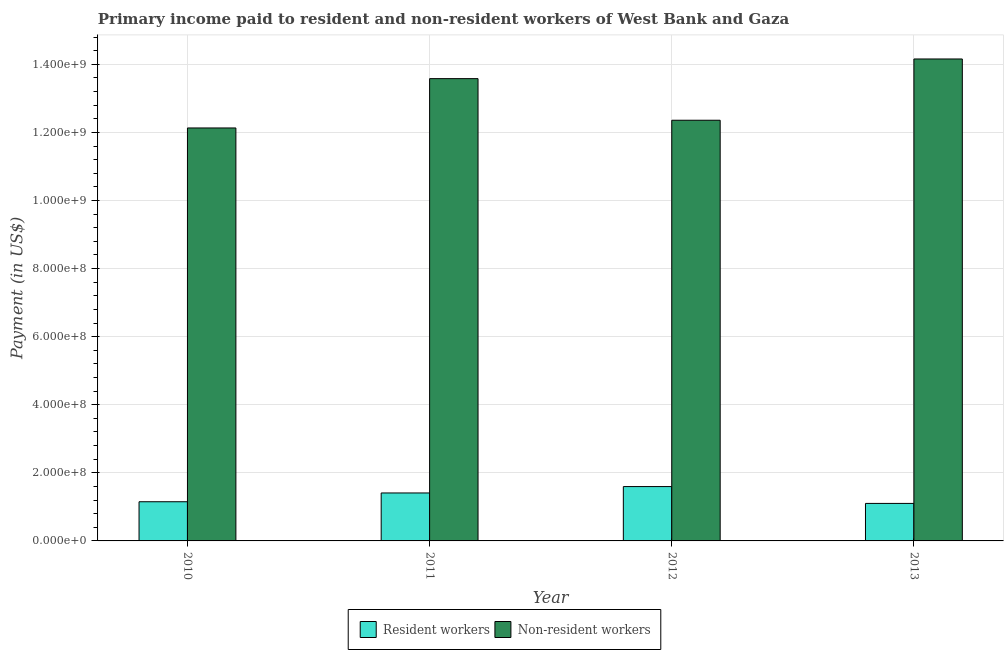How many different coloured bars are there?
Ensure brevity in your answer.  2. Are the number of bars per tick equal to the number of legend labels?
Your answer should be compact. Yes. Are the number of bars on each tick of the X-axis equal?
Your answer should be very brief. Yes. How many bars are there on the 4th tick from the right?
Your response must be concise. 2. What is the label of the 1st group of bars from the left?
Keep it short and to the point. 2010. What is the payment made to resident workers in 2013?
Your response must be concise. 1.10e+08. Across all years, what is the maximum payment made to resident workers?
Your answer should be compact. 1.60e+08. Across all years, what is the minimum payment made to non-resident workers?
Your answer should be very brief. 1.21e+09. In which year was the payment made to resident workers maximum?
Your response must be concise. 2012. In which year was the payment made to resident workers minimum?
Make the answer very short. 2013. What is the total payment made to resident workers in the graph?
Your answer should be very brief. 5.26e+08. What is the difference between the payment made to resident workers in 2010 and that in 2011?
Provide a succinct answer. -2.58e+07. What is the difference between the payment made to resident workers in 2011 and the payment made to non-resident workers in 2010?
Make the answer very short. 2.58e+07. What is the average payment made to resident workers per year?
Keep it short and to the point. 1.31e+08. In the year 2010, what is the difference between the payment made to resident workers and payment made to non-resident workers?
Provide a short and direct response. 0. What is the ratio of the payment made to non-resident workers in 2010 to that in 2013?
Provide a succinct answer. 0.86. Is the payment made to resident workers in 2011 less than that in 2012?
Your response must be concise. Yes. Is the difference between the payment made to resident workers in 2010 and 2011 greater than the difference between the payment made to non-resident workers in 2010 and 2011?
Offer a very short reply. No. What is the difference between the highest and the second highest payment made to non-resident workers?
Provide a succinct answer. 5.78e+07. What is the difference between the highest and the lowest payment made to resident workers?
Ensure brevity in your answer.  4.95e+07. Is the sum of the payment made to non-resident workers in 2011 and 2012 greater than the maximum payment made to resident workers across all years?
Offer a terse response. Yes. What does the 1st bar from the left in 2012 represents?
Keep it short and to the point. Resident workers. What does the 1st bar from the right in 2012 represents?
Provide a succinct answer. Non-resident workers. How many bars are there?
Give a very brief answer. 8. Are all the bars in the graph horizontal?
Provide a short and direct response. No. Are the values on the major ticks of Y-axis written in scientific E-notation?
Offer a very short reply. Yes. Does the graph contain any zero values?
Give a very brief answer. No. What is the title of the graph?
Provide a succinct answer. Primary income paid to resident and non-resident workers of West Bank and Gaza. Does "Nitrous oxide emissions" appear as one of the legend labels in the graph?
Ensure brevity in your answer.  No. What is the label or title of the Y-axis?
Give a very brief answer. Payment (in US$). What is the Payment (in US$) in Resident workers in 2010?
Ensure brevity in your answer.  1.15e+08. What is the Payment (in US$) in Non-resident workers in 2010?
Make the answer very short. 1.21e+09. What is the Payment (in US$) in Resident workers in 2011?
Provide a short and direct response. 1.41e+08. What is the Payment (in US$) of Non-resident workers in 2011?
Your response must be concise. 1.36e+09. What is the Payment (in US$) in Resident workers in 2012?
Give a very brief answer. 1.60e+08. What is the Payment (in US$) in Non-resident workers in 2012?
Provide a short and direct response. 1.24e+09. What is the Payment (in US$) in Resident workers in 2013?
Your answer should be compact. 1.10e+08. What is the Payment (in US$) in Non-resident workers in 2013?
Offer a very short reply. 1.42e+09. Across all years, what is the maximum Payment (in US$) of Resident workers?
Offer a very short reply. 1.60e+08. Across all years, what is the maximum Payment (in US$) in Non-resident workers?
Your answer should be very brief. 1.42e+09. Across all years, what is the minimum Payment (in US$) of Resident workers?
Offer a very short reply. 1.10e+08. Across all years, what is the minimum Payment (in US$) in Non-resident workers?
Your response must be concise. 1.21e+09. What is the total Payment (in US$) in Resident workers in the graph?
Give a very brief answer. 5.26e+08. What is the total Payment (in US$) of Non-resident workers in the graph?
Provide a succinct answer. 5.22e+09. What is the difference between the Payment (in US$) in Resident workers in 2010 and that in 2011?
Your response must be concise. -2.58e+07. What is the difference between the Payment (in US$) in Non-resident workers in 2010 and that in 2011?
Keep it short and to the point. -1.45e+08. What is the difference between the Payment (in US$) of Resident workers in 2010 and that in 2012?
Make the answer very short. -4.46e+07. What is the difference between the Payment (in US$) in Non-resident workers in 2010 and that in 2012?
Provide a short and direct response. -2.27e+07. What is the difference between the Payment (in US$) of Resident workers in 2010 and that in 2013?
Your response must be concise. 4.90e+06. What is the difference between the Payment (in US$) of Non-resident workers in 2010 and that in 2013?
Offer a terse response. -2.03e+08. What is the difference between the Payment (in US$) of Resident workers in 2011 and that in 2012?
Your response must be concise. -1.88e+07. What is the difference between the Payment (in US$) in Non-resident workers in 2011 and that in 2012?
Provide a short and direct response. 1.22e+08. What is the difference between the Payment (in US$) in Resident workers in 2011 and that in 2013?
Offer a very short reply. 3.07e+07. What is the difference between the Payment (in US$) in Non-resident workers in 2011 and that in 2013?
Offer a terse response. -5.78e+07. What is the difference between the Payment (in US$) of Resident workers in 2012 and that in 2013?
Ensure brevity in your answer.  4.95e+07. What is the difference between the Payment (in US$) of Non-resident workers in 2012 and that in 2013?
Your answer should be very brief. -1.80e+08. What is the difference between the Payment (in US$) in Resident workers in 2010 and the Payment (in US$) in Non-resident workers in 2011?
Make the answer very short. -1.24e+09. What is the difference between the Payment (in US$) in Resident workers in 2010 and the Payment (in US$) in Non-resident workers in 2012?
Your response must be concise. -1.12e+09. What is the difference between the Payment (in US$) in Resident workers in 2010 and the Payment (in US$) in Non-resident workers in 2013?
Your response must be concise. -1.30e+09. What is the difference between the Payment (in US$) of Resident workers in 2011 and the Payment (in US$) of Non-resident workers in 2012?
Ensure brevity in your answer.  -1.10e+09. What is the difference between the Payment (in US$) of Resident workers in 2011 and the Payment (in US$) of Non-resident workers in 2013?
Your response must be concise. -1.28e+09. What is the difference between the Payment (in US$) in Resident workers in 2012 and the Payment (in US$) in Non-resident workers in 2013?
Ensure brevity in your answer.  -1.26e+09. What is the average Payment (in US$) in Resident workers per year?
Your response must be concise. 1.31e+08. What is the average Payment (in US$) of Non-resident workers per year?
Offer a terse response. 1.31e+09. In the year 2010, what is the difference between the Payment (in US$) in Resident workers and Payment (in US$) in Non-resident workers?
Ensure brevity in your answer.  -1.10e+09. In the year 2011, what is the difference between the Payment (in US$) in Resident workers and Payment (in US$) in Non-resident workers?
Provide a short and direct response. -1.22e+09. In the year 2012, what is the difference between the Payment (in US$) in Resident workers and Payment (in US$) in Non-resident workers?
Offer a terse response. -1.08e+09. In the year 2013, what is the difference between the Payment (in US$) of Resident workers and Payment (in US$) of Non-resident workers?
Your response must be concise. -1.31e+09. What is the ratio of the Payment (in US$) of Resident workers in 2010 to that in 2011?
Keep it short and to the point. 0.82. What is the ratio of the Payment (in US$) of Non-resident workers in 2010 to that in 2011?
Provide a succinct answer. 0.89. What is the ratio of the Payment (in US$) of Resident workers in 2010 to that in 2012?
Give a very brief answer. 0.72. What is the ratio of the Payment (in US$) of Non-resident workers in 2010 to that in 2012?
Offer a terse response. 0.98. What is the ratio of the Payment (in US$) in Resident workers in 2010 to that in 2013?
Your answer should be compact. 1.04. What is the ratio of the Payment (in US$) in Non-resident workers in 2010 to that in 2013?
Ensure brevity in your answer.  0.86. What is the ratio of the Payment (in US$) in Resident workers in 2011 to that in 2012?
Give a very brief answer. 0.88. What is the ratio of the Payment (in US$) in Non-resident workers in 2011 to that in 2012?
Offer a very short reply. 1.1. What is the ratio of the Payment (in US$) in Resident workers in 2011 to that in 2013?
Offer a very short reply. 1.28. What is the ratio of the Payment (in US$) in Non-resident workers in 2011 to that in 2013?
Your answer should be very brief. 0.96. What is the ratio of the Payment (in US$) in Resident workers in 2012 to that in 2013?
Make the answer very short. 1.45. What is the ratio of the Payment (in US$) of Non-resident workers in 2012 to that in 2013?
Offer a very short reply. 0.87. What is the difference between the highest and the second highest Payment (in US$) of Resident workers?
Provide a short and direct response. 1.88e+07. What is the difference between the highest and the second highest Payment (in US$) of Non-resident workers?
Provide a succinct answer. 5.78e+07. What is the difference between the highest and the lowest Payment (in US$) of Resident workers?
Your answer should be very brief. 4.95e+07. What is the difference between the highest and the lowest Payment (in US$) in Non-resident workers?
Make the answer very short. 2.03e+08. 